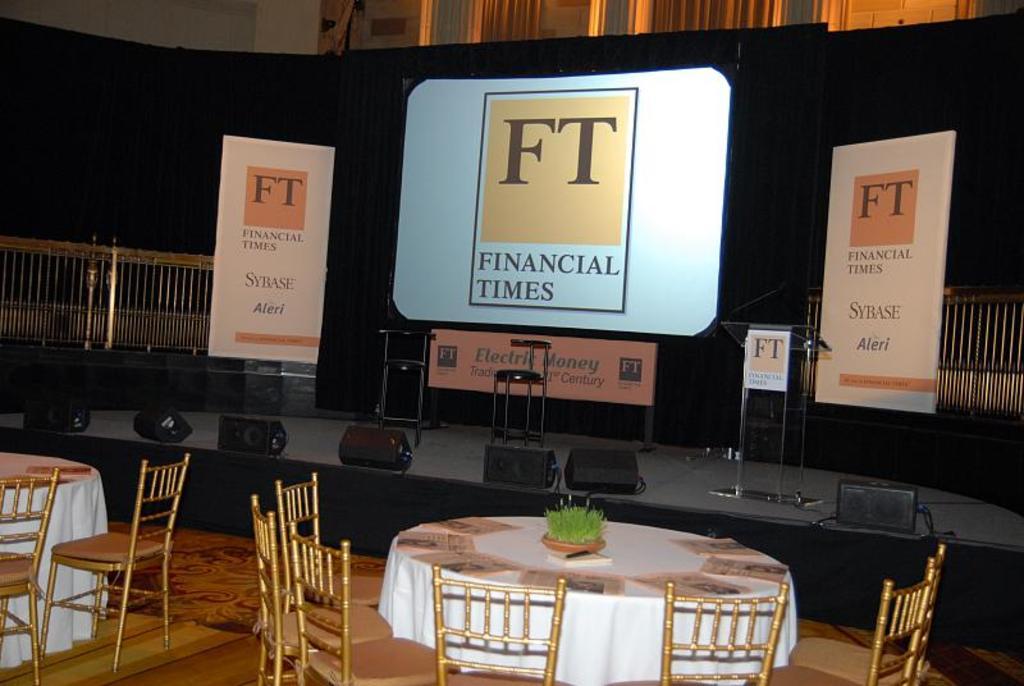What does the ft stand for?
Ensure brevity in your answer.  Financial times. What kind of money is being advertised?
Offer a very short reply. Electric money. 